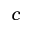<formula> <loc_0><loc_0><loc_500><loc_500>c</formula> 